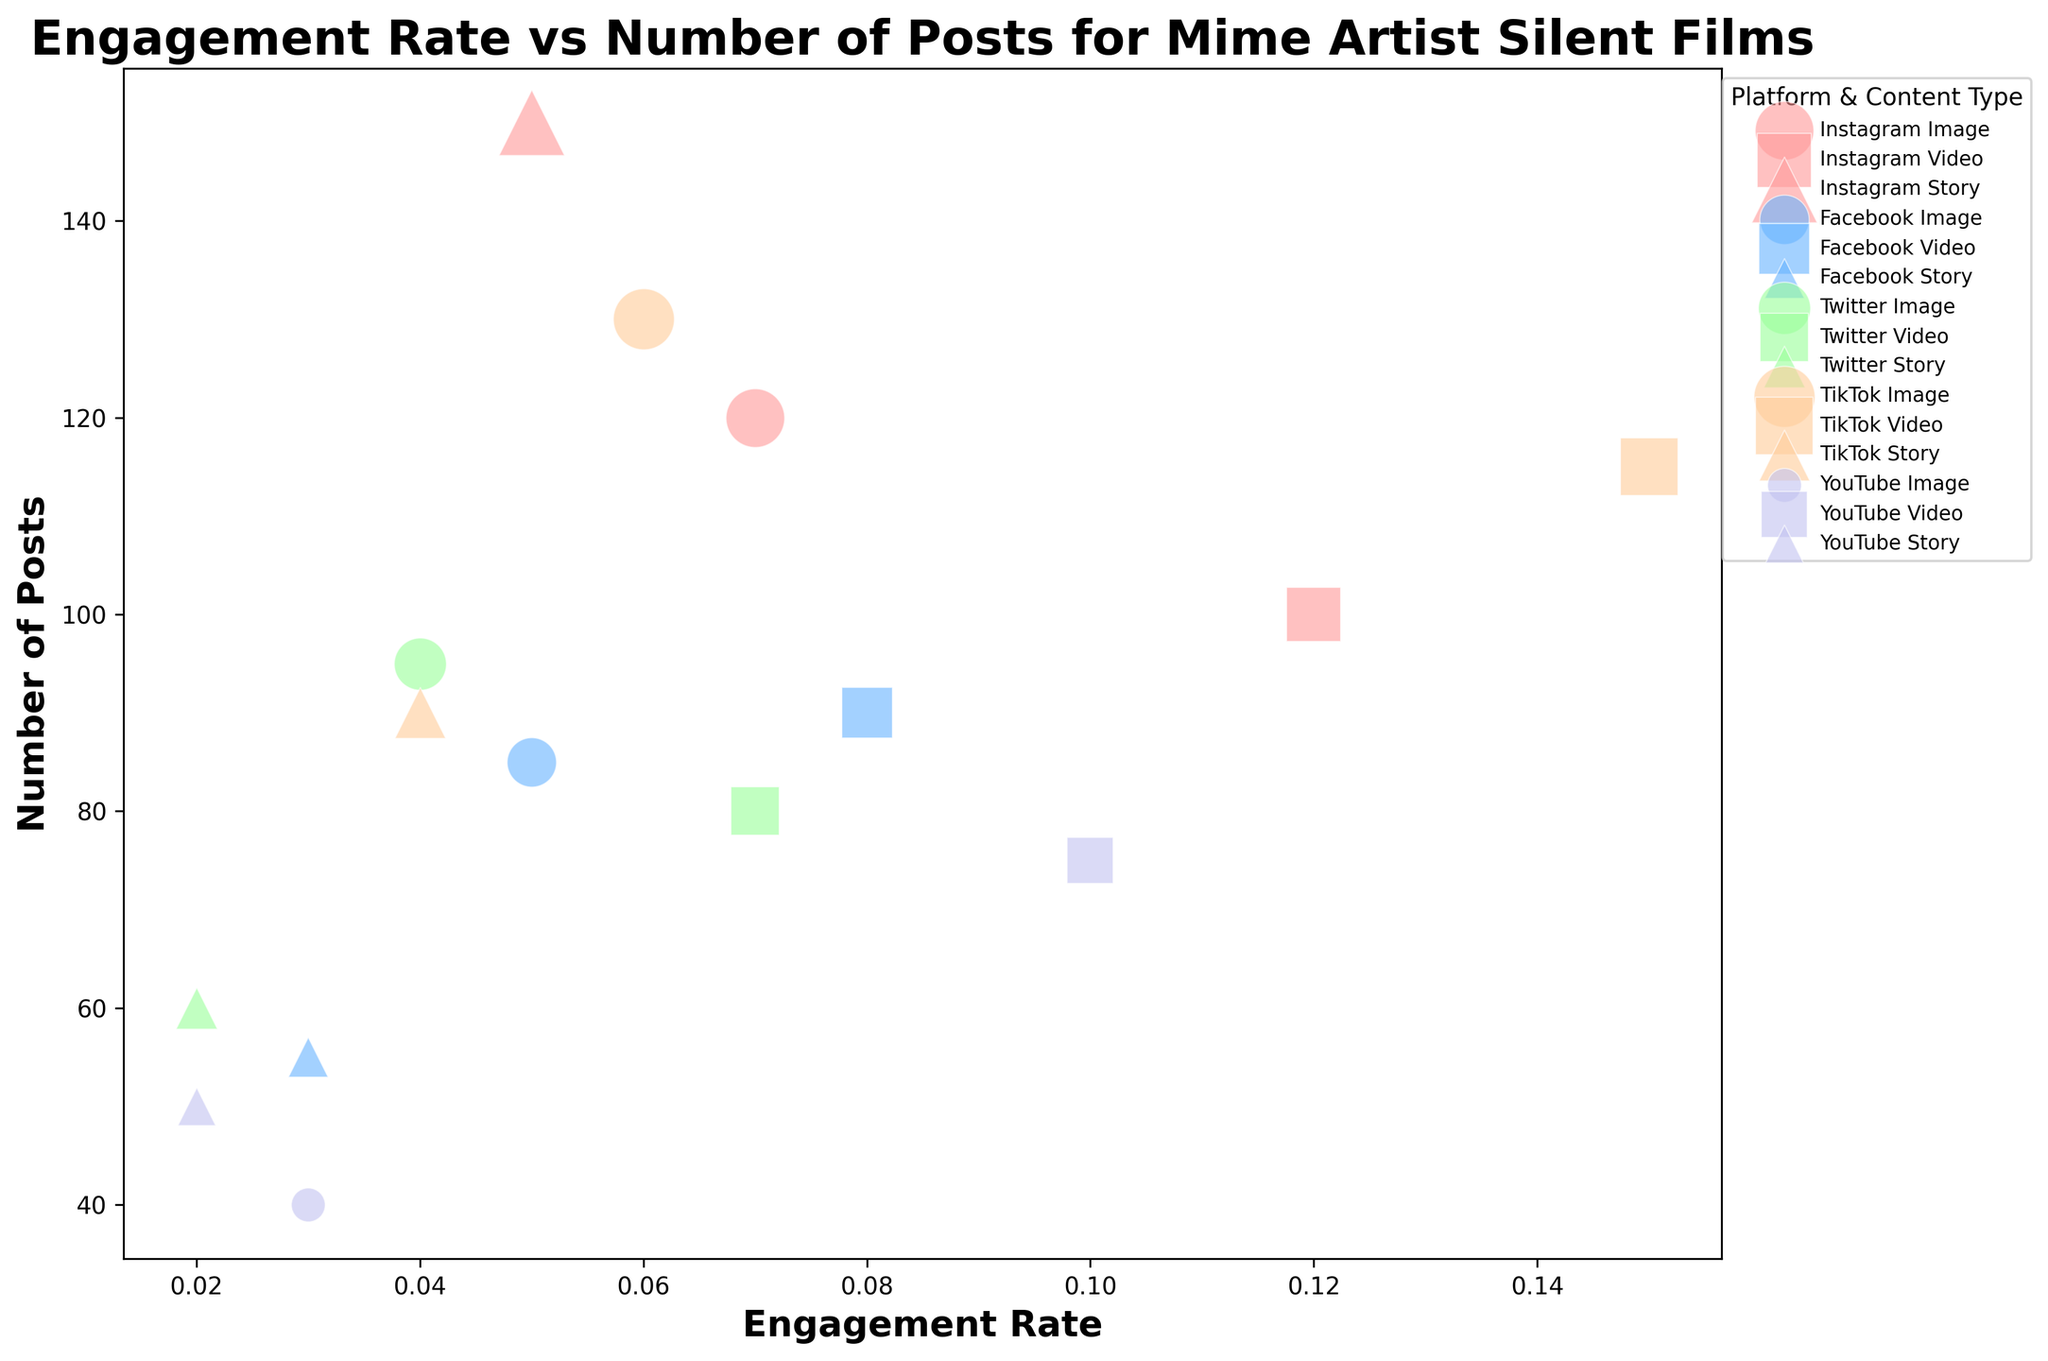What platform and content type has the highest engagement rate? Look at the figure for the bubble that is positioned furthest to the right on the x-axis (engagement rate). The platform and content type corresponding to that bubble represent the highest engagement rate.
Answer: TikTok Video Which platform and content type combination has the most number of posts? Check the largest bubbles, as the size of the bubbles represents the number of posts. The largest bubble in the chart corresponds to the combination with the most posts.
Answer: Instagram Story Which platform has the highest average engagement rate across all content types? Calculate the average engagement rate for each platform by averaging the x-coordinates of the bubbles within each platform. The platform with the highest average x-coordinate has the highest average engagement rate.
Answer: TikTok Is the engagement rate for Facebook videos higher than for Facebook stories? Compare the x-positions of the bubbles labeled as Facebook Video and Facebook Story. The x-position represents the engagement rate. If the Facebook Video bubble is further to the right, it has a higher engagement rate.
Answer: Yes What is the combined number of posts for all video content types across platforms? Add the sizes of all bubbles that represent video content (square-shaped bubbles) across different platforms.
Answer: 460 Which content type on Instagram has the lowest engagement rate? Identify the Instagram bubbles and compare their x-positions. The bubble with the smallest x-position represents the lowest engagement rate.
Answer: Story How does the number of posts for Twitter images compare to Twitter videos? Compare the size of the bubbles representing Twitter Image and Twitter Video. The larger bubble indicates a higher number of posts.
Answer: There are more posts for Twitter Images By how much does the engagement rate for YouTube videos exceed that of YouTube stories? Find the engagement rate of YouTube Video and YouTube Story by identifying their x-positions. Subtract the engagement rate of YouTube Story from that of YouTube Video.
Answer: 0.08 Which platform has more content types with an engagement rate above 0.1? Identify the bubbles with an engagement rate (x-coordinate) greater than 0.1 and count the number of content types for each platform. The platform with the highest count has more content types above 0.1 engagement rate.
Answer: TikTok How does the engagement rate for TikTok images differ from Instagram images? Compare the x-positions of the bubbles representing TikTok Image and Instagram Image. The difference in their positions will give the difference in engagement rates.
Answer: TikTok images have 0.01 lower engagement rate than Instagram images 